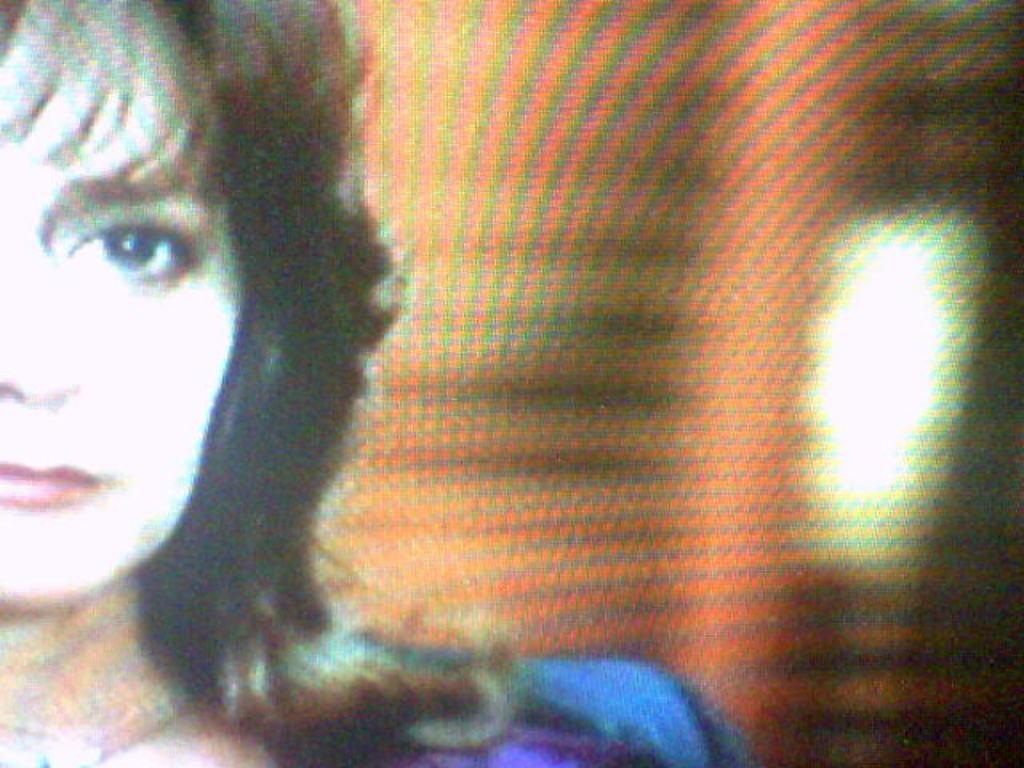Can you describe this image briefly? This image consists of a screen in which there is a woman wearing blue dress. 